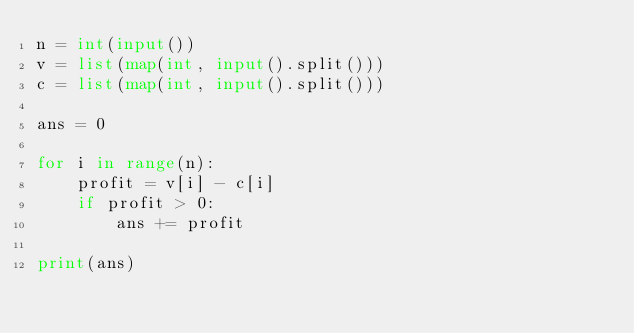Convert code to text. <code><loc_0><loc_0><loc_500><loc_500><_Python_>n = int(input())
v = list(map(int, input().split()))
c = list(map(int, input().split()))

ans = 0

for i in range(n):
    profit = v[i] - c[i]
    if profit > 0:
        ans += profit

print(ans)</code> 